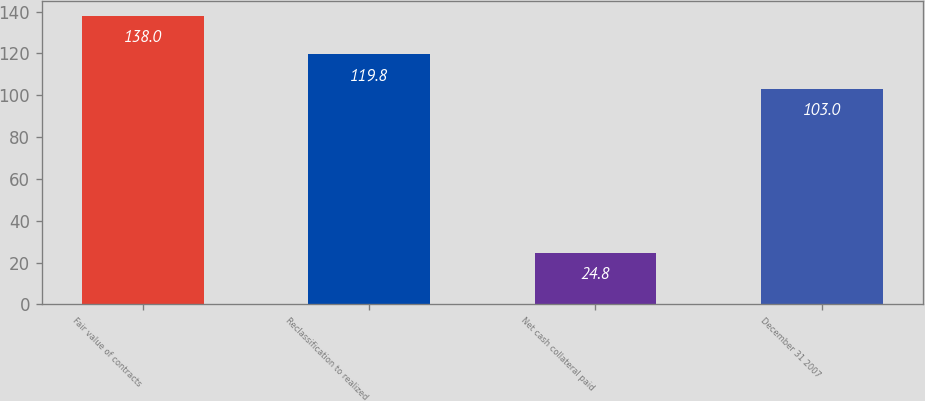Convert chart to OTSL. <chart><loc_0><loc_0><loc_500><loc_500><bar_chart><fcel>Fair value of contracts<fcel>Reclassification to realized<fcel>Net cash collateral paid<fcel>December 31 2007<nl><fcel>138<fcel>119.8<fcel>24.8<fcel>103<nl></chart> 